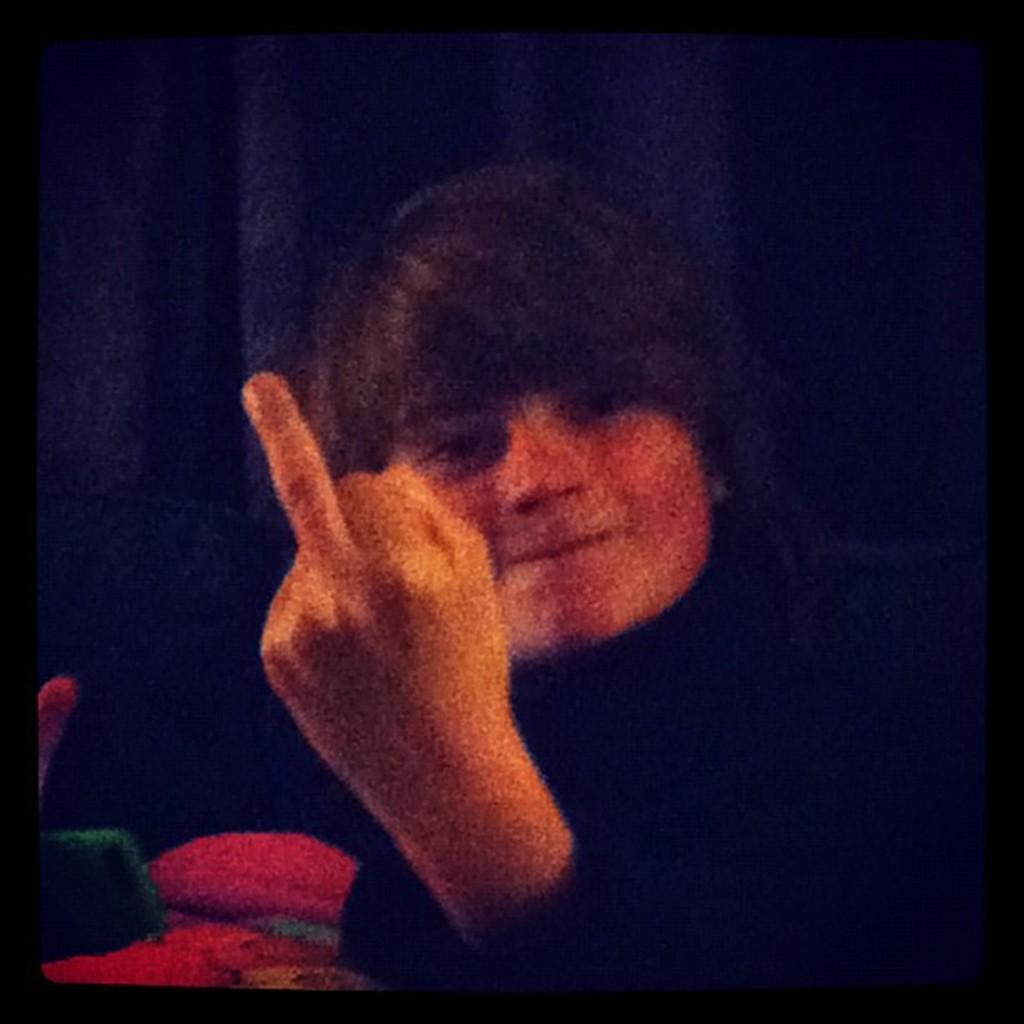Who is in the image? There is a person in the image. What is the person wearing? The person is wearing a black dress. Can you describe the background of the image? There are objects in the background of the image, some of which are red and green in color. There is also a black colored cloth in the background. What type of approval does the yak in the image require to cross the boundary? There is no yak present in the image, and therefore no approval or boundary is relevant to the image. 